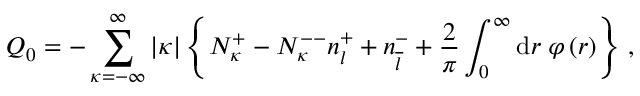Convert formula to latex. <formula><loc_0><loc_0><loc_500><loc_500>Q _ { 0 } = - \sum _ { \kappa = - \infty } ^ { \infty } | \kappa | \left \{ N _ { \kappa } ^ { + } - N _ { \kappa } ^ { - - } n _ { l } ^ { + } + n _ { \overline { l } } ^ { - } + \frac { 2 } { \pi } \int _ { 0 } ^ { \infty } d r \, \varphi \left ( r \right ) \right \} \, ,</formula> 